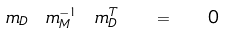Convert formula to latex. <formula><loc_0><loc_0><loc_500><loc_500>m _ { D } \ m _ { M } ^ { - 1 } \ m _ { D } ^ { T } \ \ = \ \ { 0 }</formula> 